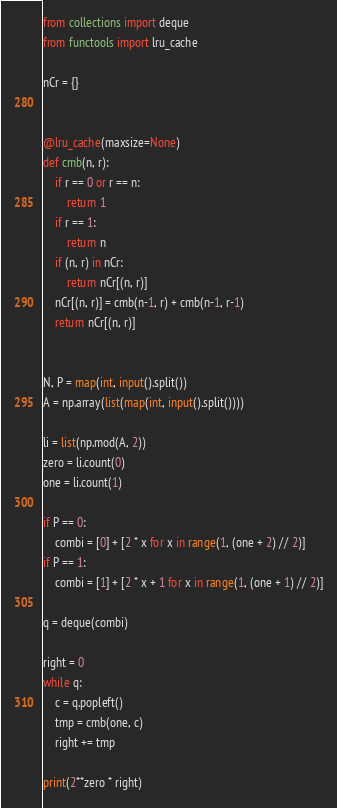<code> <loc_0><loc_0><loc_500><loc_500><_Python_>from collections import deque
from functools import lru_cache

nCr = {}


@lru_cache(maxsize=None)
def cmb(n, r):
    if r == 0 or r == n:
        return 1
    if r == 1:
        return n
    if (n, r) in nCr:
        return nCr[(n, r)]
    nCr[(n, r)] = cmb(n-1, r) + cmb(n-1, r-1)
    return nCr[(n, r)]


N, P = map(int, input().split())
A = np.array(list(map(int, input().split())))

li = list(np.mod(A, 2))
zero = li.count(0)
one = li.count(1)

if P == 0:
    combi = [0] + [2 * x for x in range(1, (one + 2) // 2)]
if P == 1:
    combi = [1] + [2 * x + 1 for x in range(1, (one + 1) // 2)]

q = deque(combi)

right = 0
while q:
    c = q.popleft()
    tmp = cmb(one, c)
    right += tmp

print(2**zero * right)</code> 